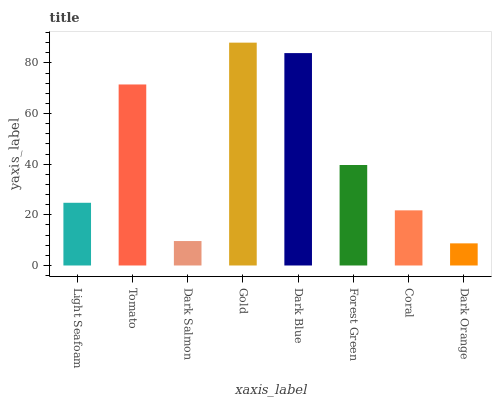Is Dark Orange the minimum?
Answer yes or no. Yes. Is Gold the maximum?
Answer yes or no. Yes. Is Tomato the minimum?
Answer yes or no. No. Is Tomato the maximum?
Answer yes or no. No. Is Tomato greater than Light Seafoam?
Answer yes or no. Yes. Is Light Seafoam less than Tomato?
Answer yes or no. Yes. Is Light Seafoam greater than Tomato?
Answer yes or no. No. Is Tomato less than Light Seafoam?
Answer yes or no. No. Is Forest Green the high median?
Answer yes or no. Yes. Is Light Seafoam the low median?
Answer yes or no. Yes. Is Light Seafoam the high median?
Answer yes or no. No. Is Gold the low median?
Answer yes or no. No. 